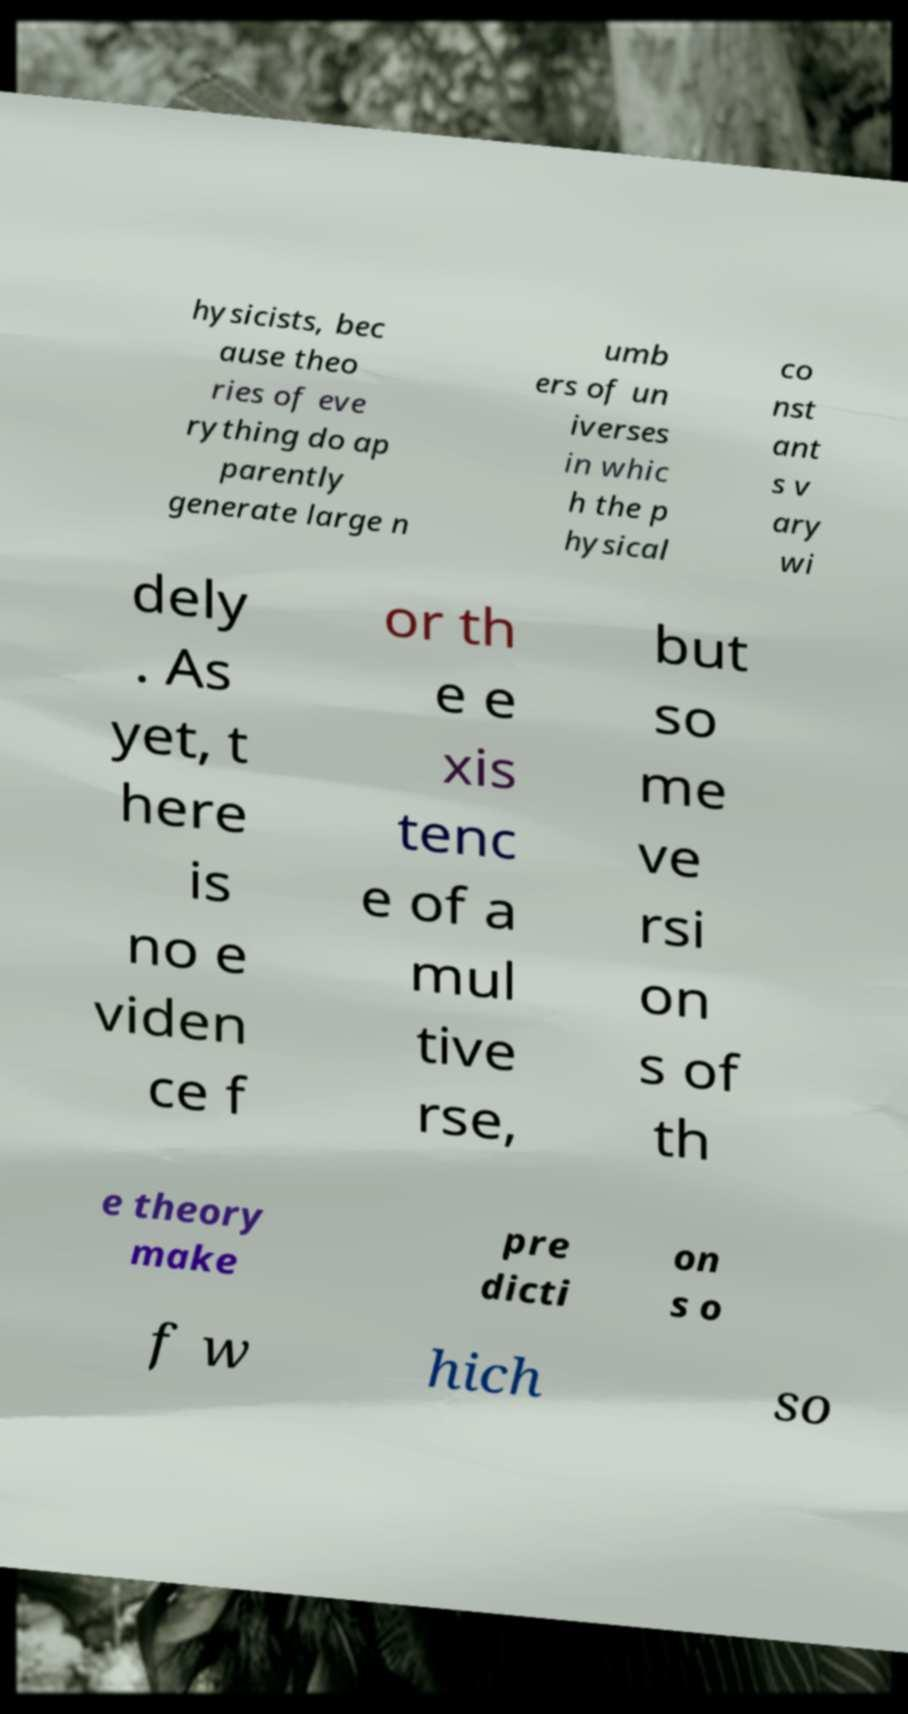What messages or text are displayed in this image? I need them in a readable, typed format. hysicists, bec ause theo ries of eve rything do ap parently generate large n umb ers of un iverses in whic h the p hysical co nst ant s v ary wi dely . As yet, t here is no e viden ce f or th e e xis tenc e of a mul tive rse, but so me ve rsi on s of th e theory make pre dicti on s o f w hich so 